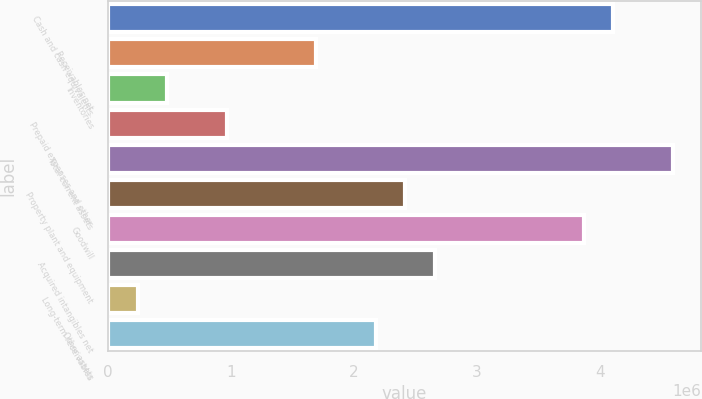<chart> <loc_0><loc_0><loc_500><loc_500><bar_chart><fcel>Cash and cash equivalents<fcel>Receivables net<fcel>Inventories<fcel>Prepaid expenses and other<fcel>Total current assets<fcel>Property plant and equipment<fcel>Goodwill<fcel>Acquired intangibles net<fcel>Long-term receivables<fcel>Other assets<nl><fcel>4.10927e+06<fcel>1.69419e+06<fcel>486647<fcel>969664<fcel>4.59229e+06<fcel>2.41871e+06<fcel>3.86776e+06<fcel>2.66022e+06<fcel>245138<fcel>2.17721e+06<nl></chart> 